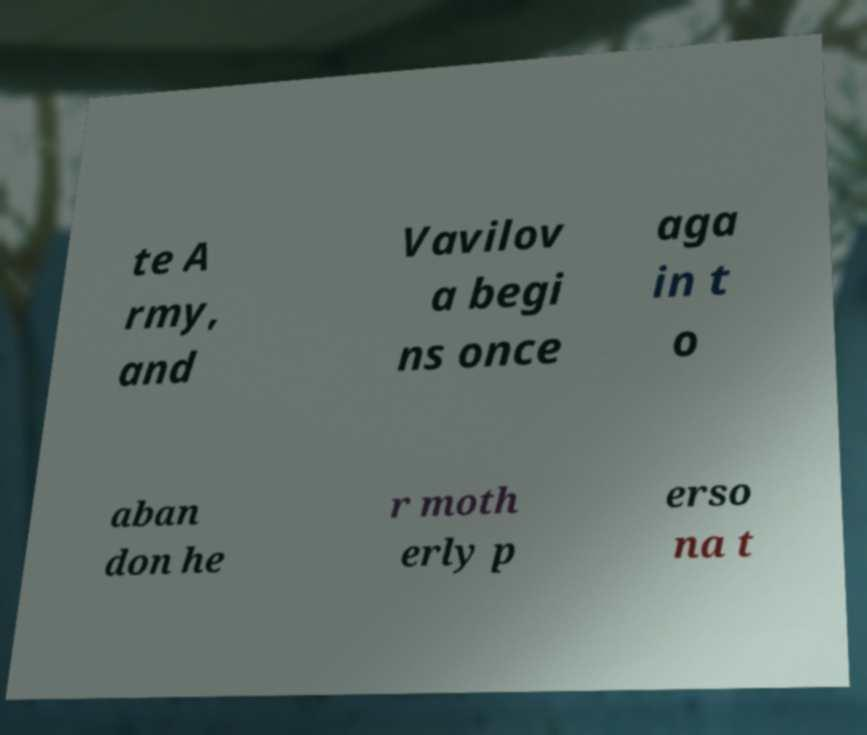Can you accurately transcribe the text from the provided image for me? te A rmy, and Vavilov a begi ns once aga in t o aban don he r moth erly p erso na t 